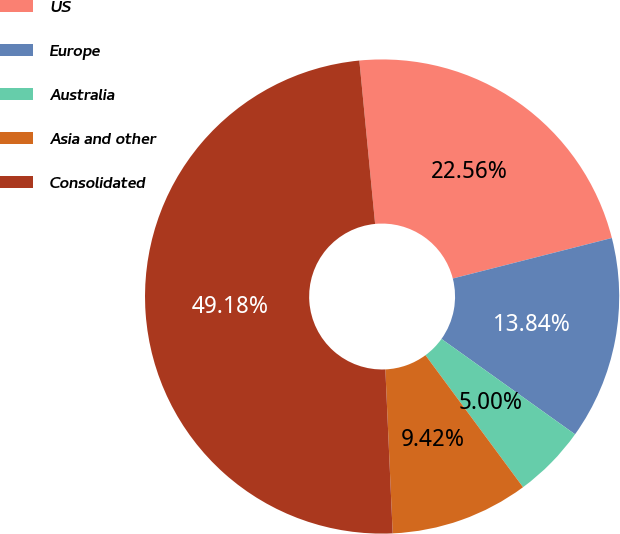Convert chart. <chart><loc_0><loc_0><loc_500><loc_500><pie_chart><fcel>US<fcel>Europe<fcel>Australia<fcel>Asia and other<fcel>Consolidated<nl><fcel>22.56%<fcel>13.84%<fcel>5.0%<fcel>9.42%<fcel>49.18%<nl></chart> 